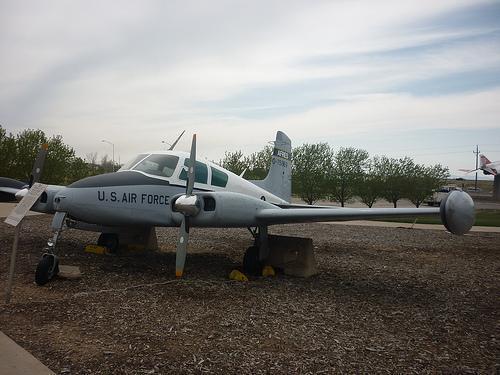How many planes?
Give a very brief answer. 1. 